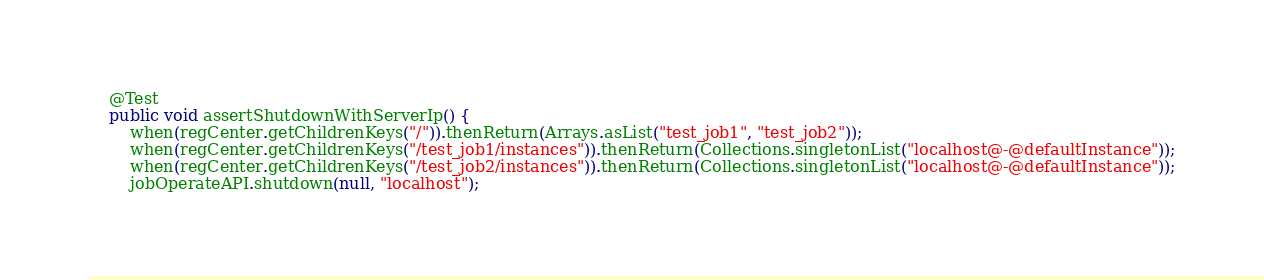Convert code to text. <code><loc_0><loc_0><loc_500><loc_500><_Java_>    @Test
    public void assertShutdownWithServerIp() {
        when(regCenter.getChildrenKeys("/")).thenReturn(Arrays.asList("test_job1", "test_job2"));
        when(regCenter.getChildrenKeys("/test_job1/instances")).thenReturn(Collections.singletonList("localhost@-@defaultInstance"));
        when(regCenter.getChildrenKeys("/test_job2/instances")).thenReturn(Collections.singletonList("localhost@-@defaultInstance"));
        jobOperateAPI.shutdown(null, "localhost");</code> 